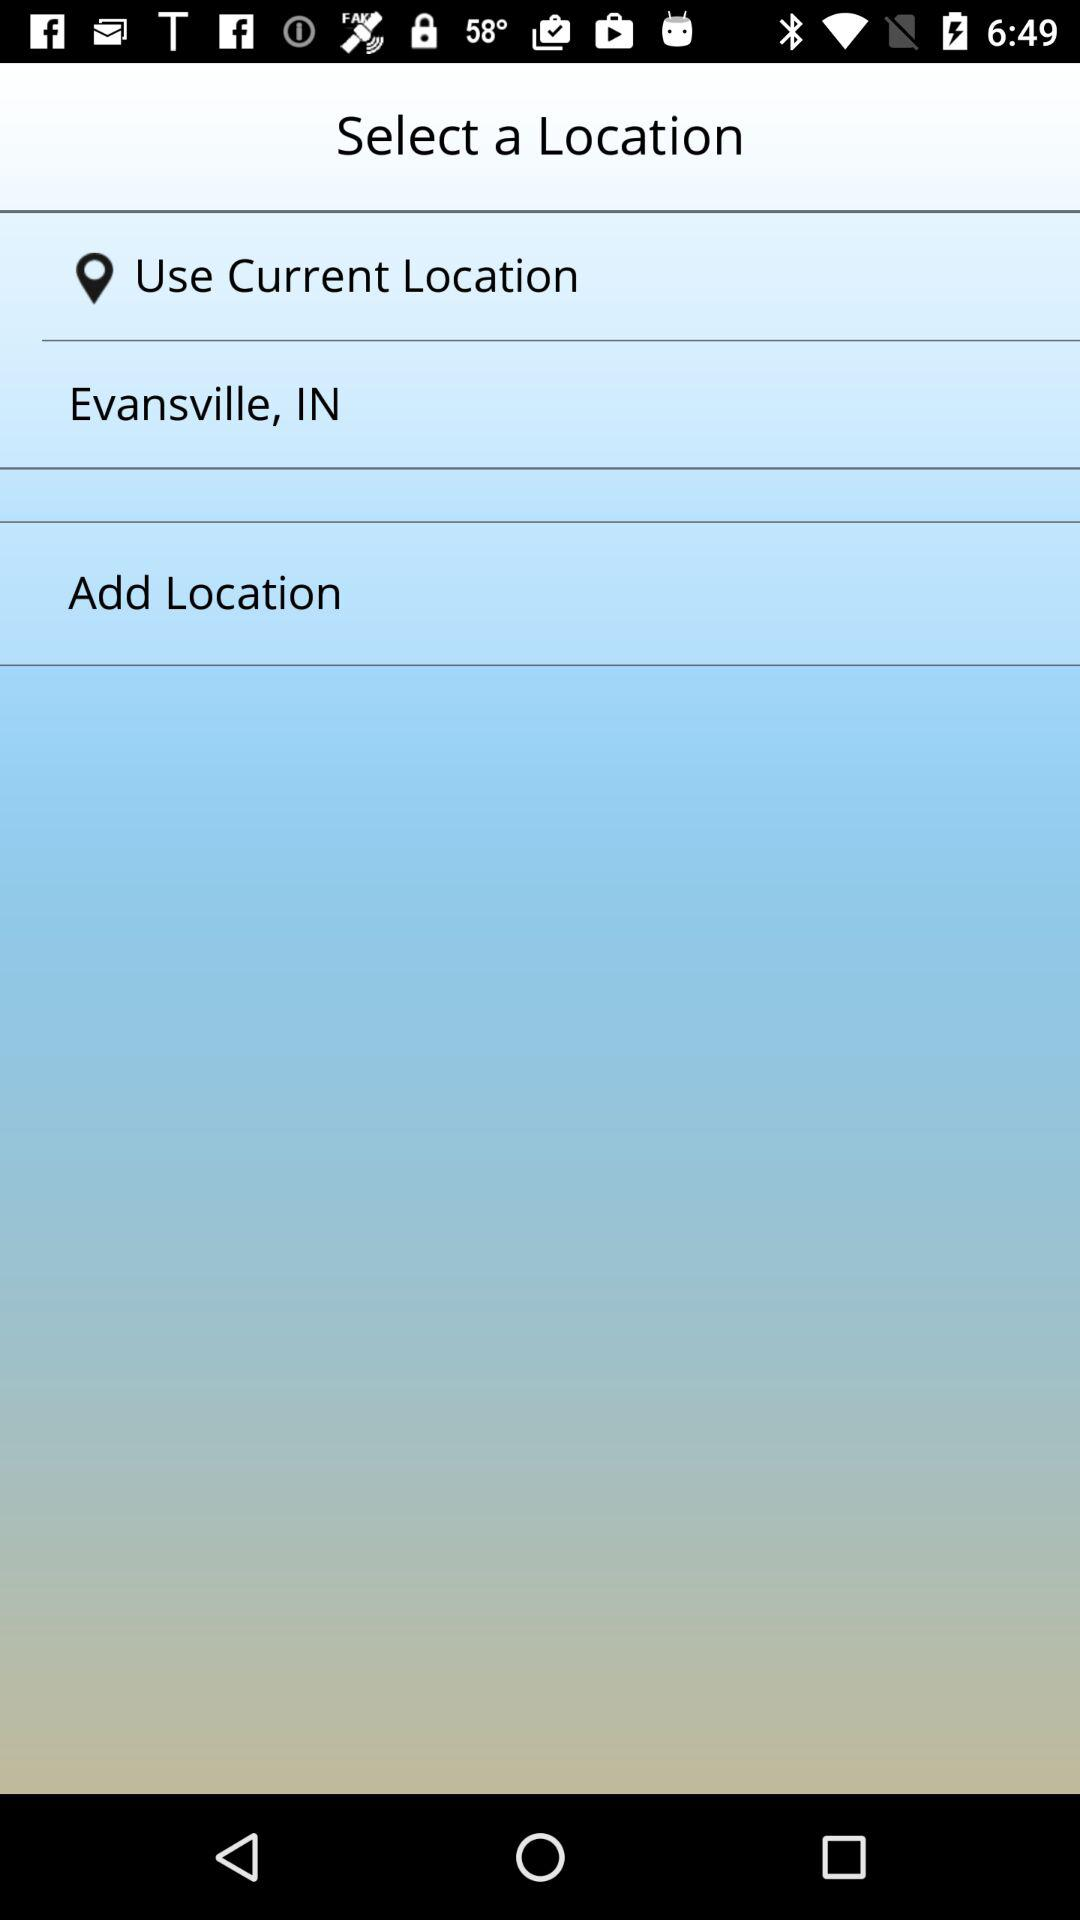What option is there for selecting a location? The options are "Use Current Location" and "Add Location". 